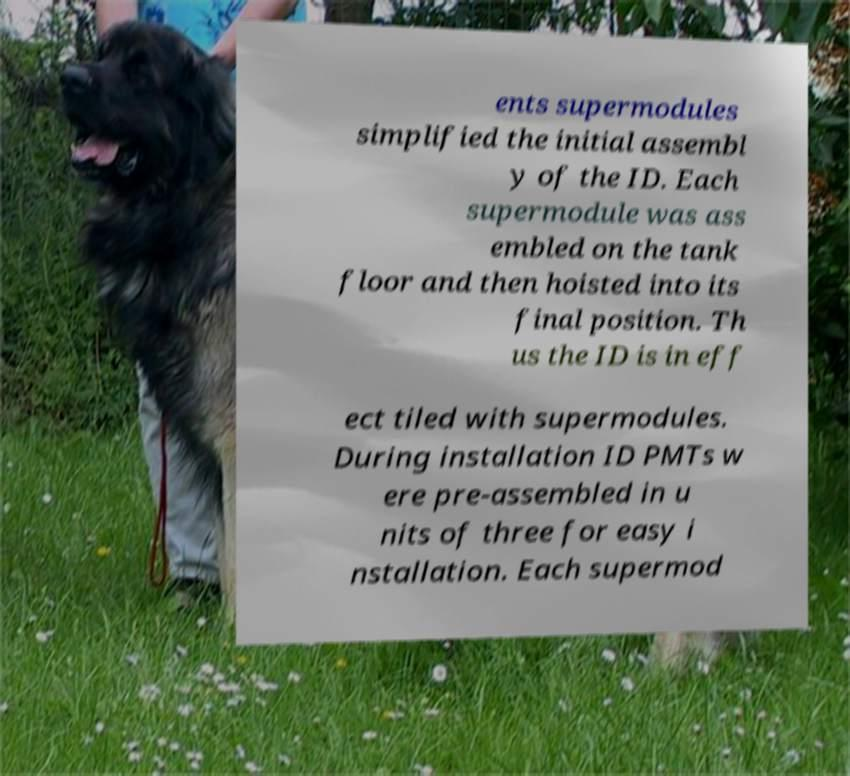What messages or text are displayed in this image? I need them in a readable, typed format. ents supermodules simplified the initial assembl y of the ID. Each supermodule was ass embled on the tank floor and then hoisted into its final position. Th us the ID is in eff ect tiled with supermodules. During installation ID PMTs w ere pre-assembled in u nits of three for easy i nstallation. Each supermod 